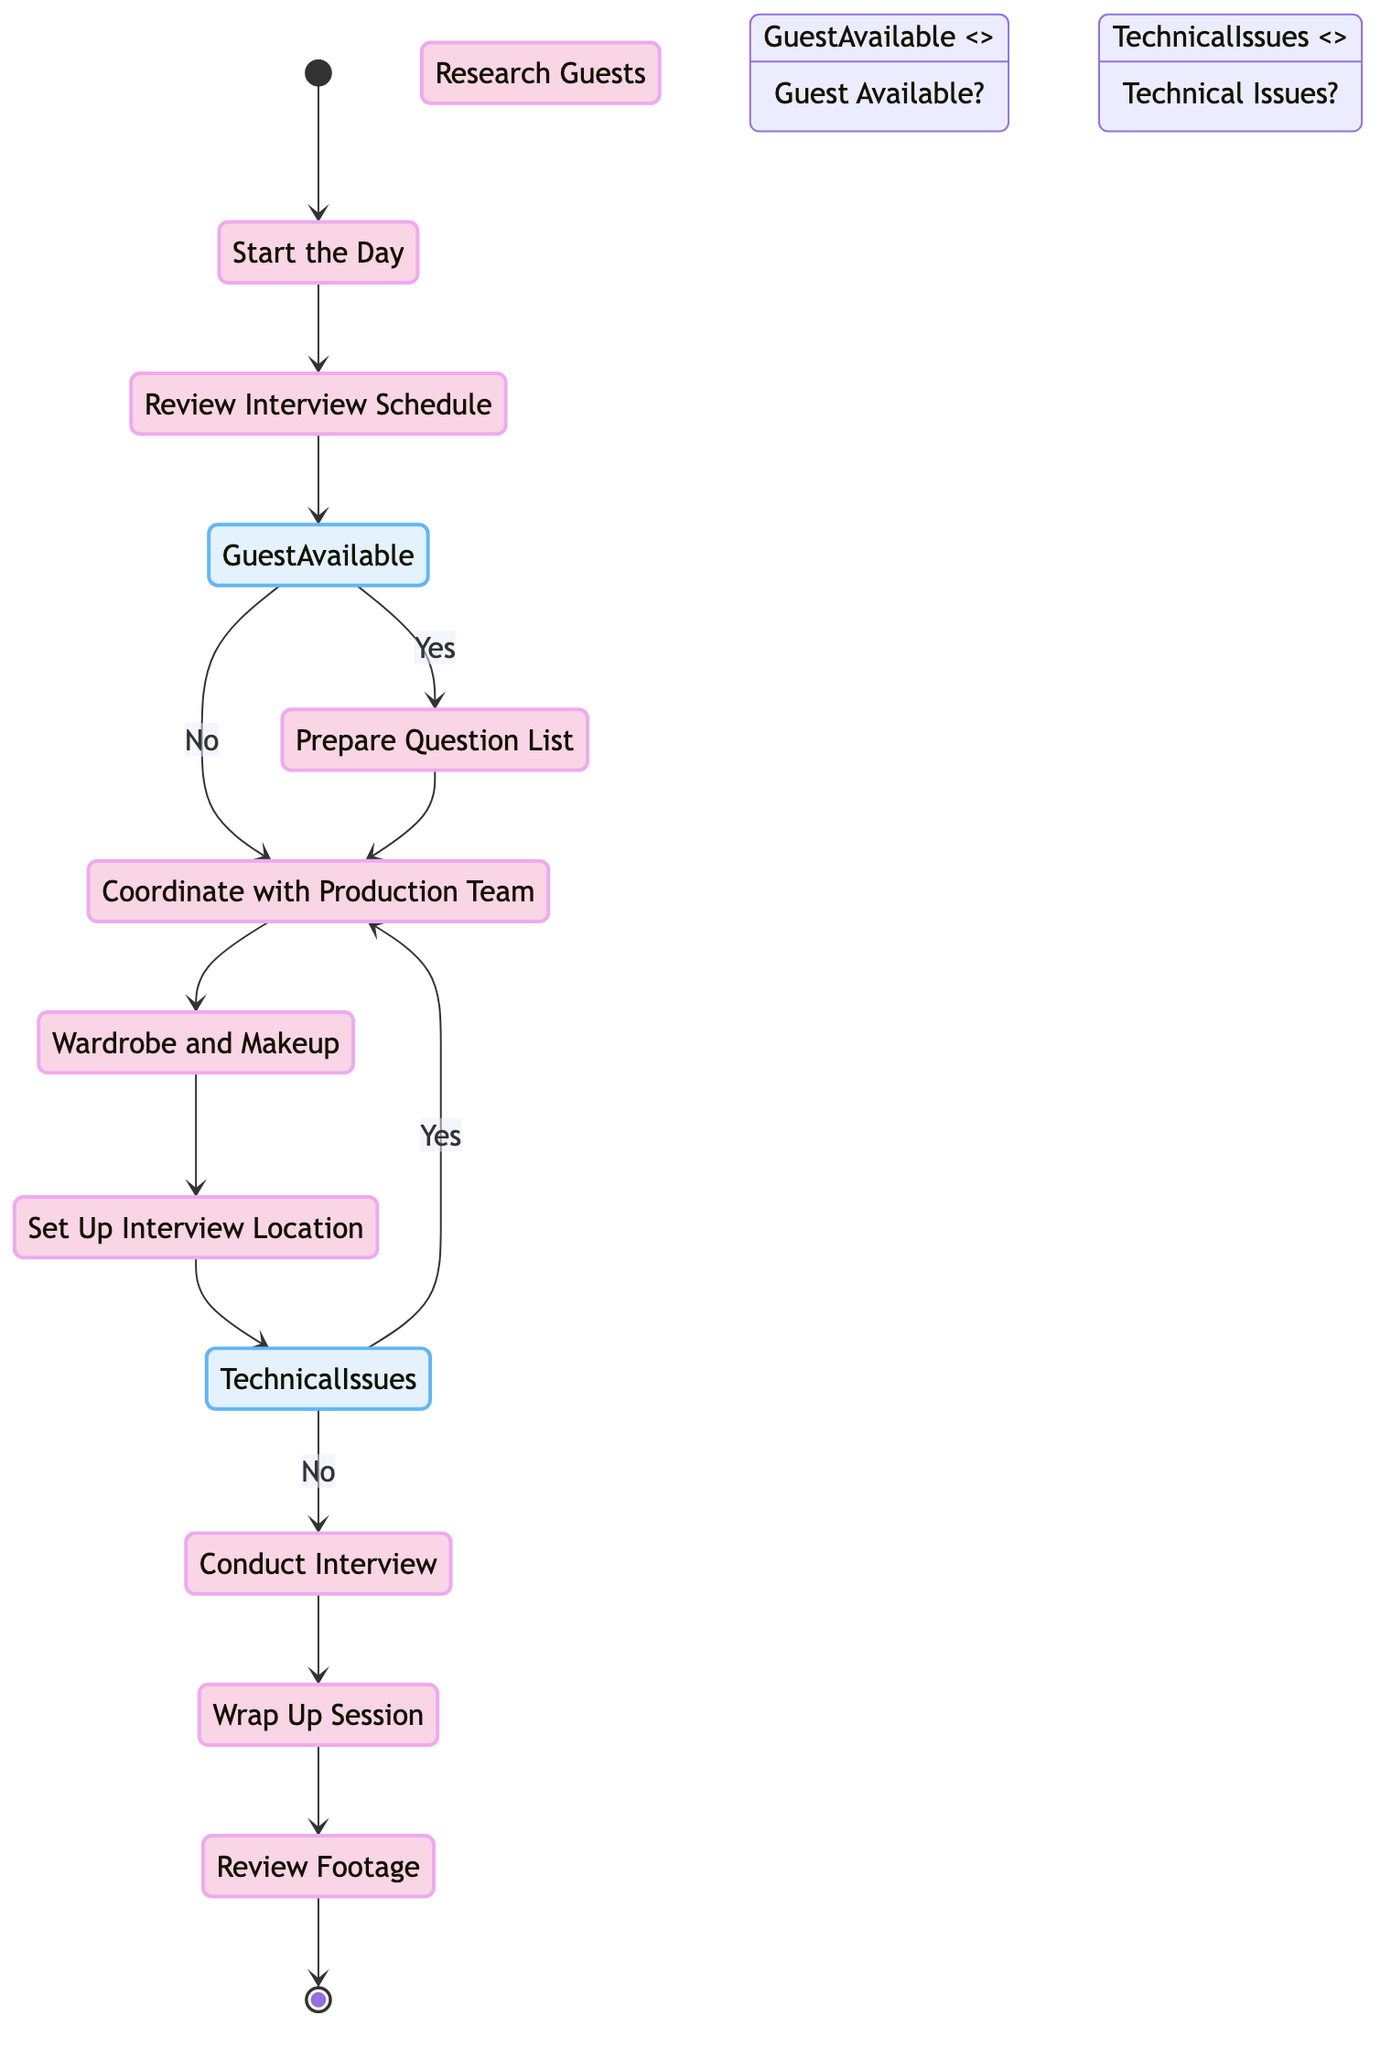What's the first activity in the diagram? The diagram begins with the starting point indicated by the arrow leading to "Start the Day," which is the first activity in the flow.
Answer: Start the Day How many activities are represented in the diagram? The diagram lists a total of eleven activities, including the start and end points. This includes "Start the Day" and "End the Day."
Answer: Eleven What decision point occurs after the "Review Interview Schedule" activity? The decision point that follows the "Review Interview Schedule" is "Guest Available?" indicating whether the guest can attend the interview.
Answer: Guest Available? If the answer to "Guest Available?" is "No," which activity follows? If the response to "Guest Available?" is "No," the next activity is "Coordinate with Production Team," as indicated by the flow from that decision point.
Answer: Coordinate with Production Team What happens if there are "Technical Issues?" during the "Set Up Interview Location" phase? If "Technical Issues?" are present, the workflow splits, leading to either "Conduct Interview" if resolved or back to "Coordinate with Production Team" for further adjustments if not solved.
Answer: Coordinate with Production Team Which two activities are directly connected after "Conduct Interview"? After "Conduct Interview," the next activity is "Wrap Up Session," which continuously flows into "Review Footage" after wrapping up.
Answer: Wrap Up Session What is the last activity listed before "End the Day"? The final activity illustrated just prior to "End the Day" is "Review Footage," where the interviewer assesses the recorded material.
Answer: Review Footage How many decision points are present in the diagram? There are two decision points explicitly stated in the diagram: "Guest Available?" and "Technical Issues?".
Answer: Two What is the last decision point in the flow? The last decision point before reaching the final activities is "Technical Issues?," occurring after setting up the interview location.
Answer: Technical Issues? 